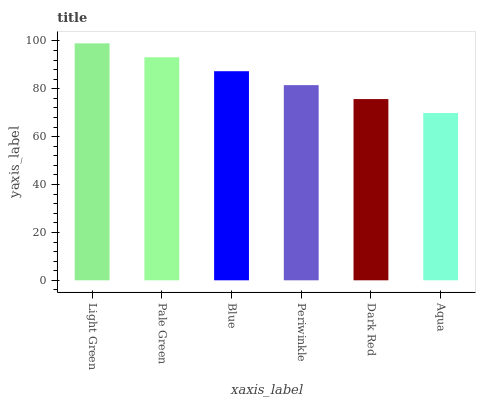Is Pale Green the minimum?
Answer yes or no. No. Is Pale Green the maximum?
Answer yes or no. No. Is Light Green greater than Pale Green?
Answer yes or no. Yes. Is Pale Green less than Light Green?
Answer yes or no. Yes. Is Pale Green greater than Light Green?
Answer yes or no. No. Is Light Green less than Pale Green?
Answer yes or no. No. Is Blue the high median?
Answer yes or no. Yes. Is Periwinkle the low median?
Answer yes or no. Yes. Is Aqua the high median?
Answer yes or no. No. Is Pale Green the low median?
Answer yes or no. No. 